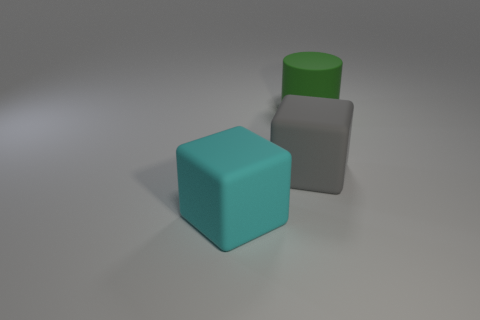Add 1 large cyan matte things. How many objects exist? 4 Subtract all cyan blocks. How many blocks are left? 1 Subtract all blocks. How many objects are left? 1 Subtract 1 cylinders. How many cylinders are left? 0 Subtract all brown cylinders. How many blue blocks are left? 0 Add 2 gray objects. How many gray objects exist? 3 Subtract 0 gray balls. How many objects are left? 3 Subtract all yellow cylinders. Subtract all red spheres. How many cylinders are left? 1 Subtract all tiny blue matte objects. Subtract all large rubber cubes. How many objects are left? 1 Add 3 gray things. How many gray things are left? 4 